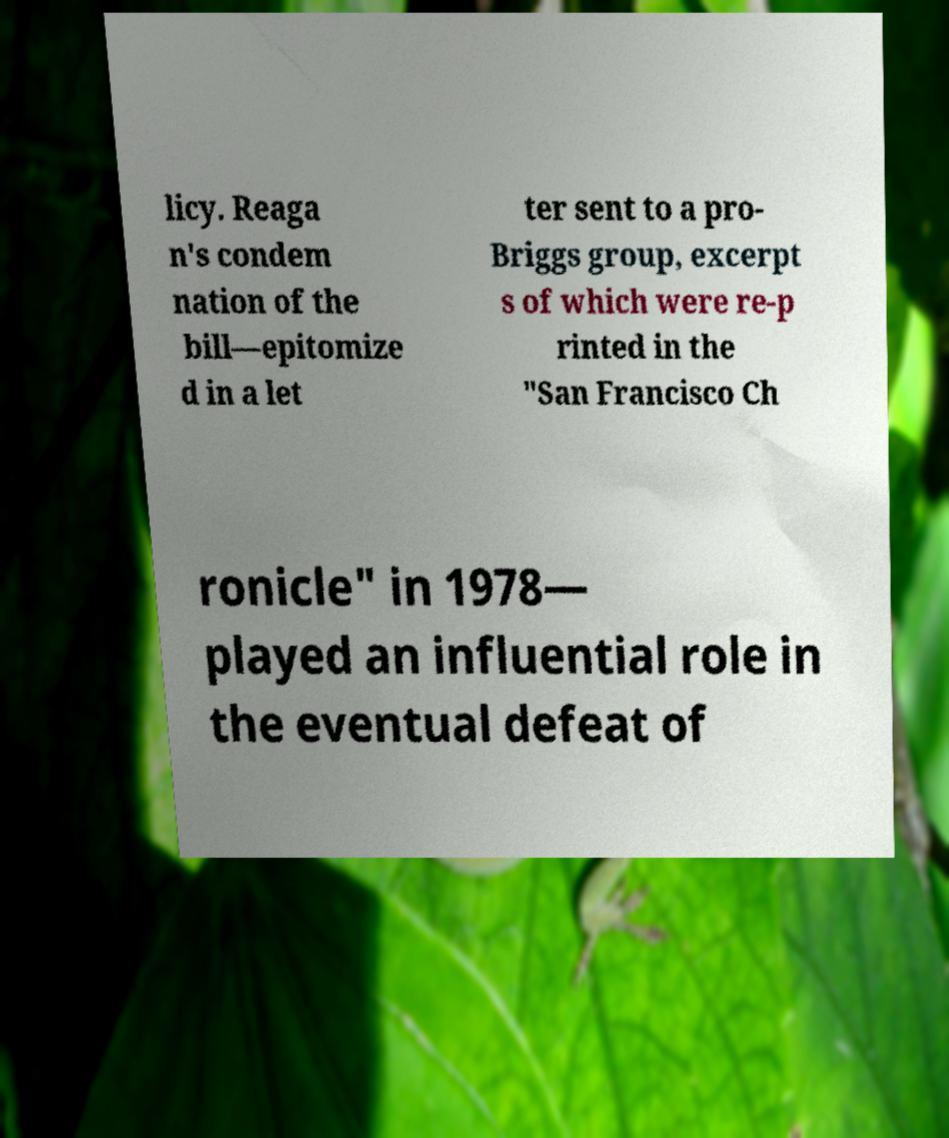Please identify and transcribe the text found in this image. licy. Reaga n's condem nation of the bill—epitomize d in a let ter sent to a pro- Briggs group, excerpt s of which were re-p rinted in the "San Francisco Ch ronicle" in 1978— played an influential role in the eventual defeat of 